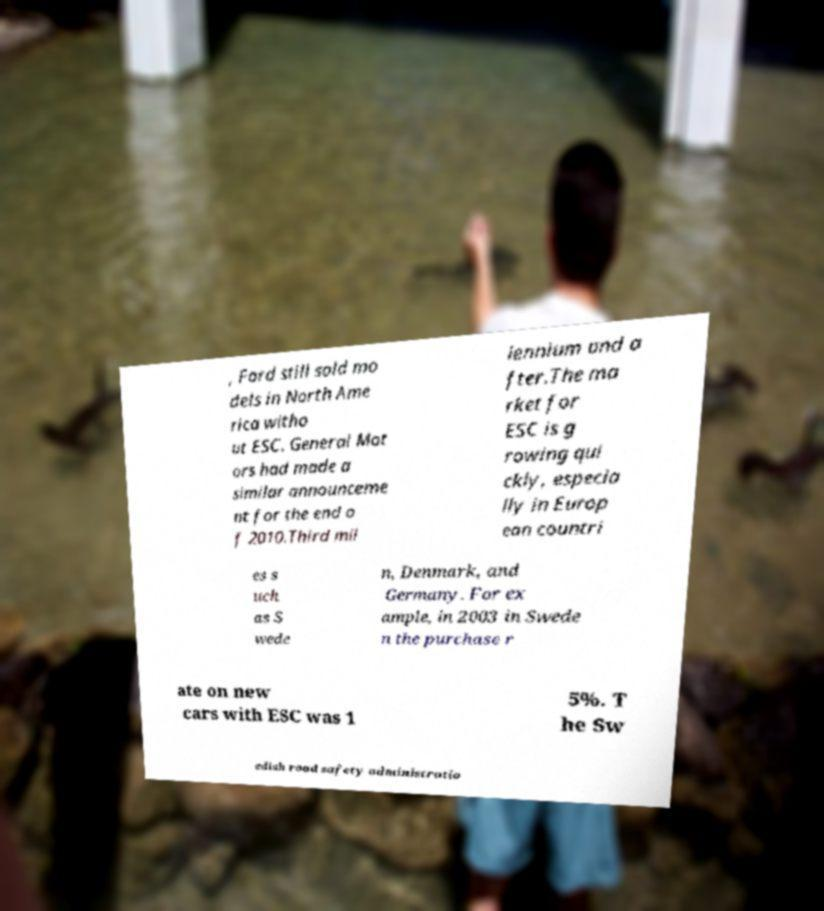Can you read and provide the text displayed in the image?This photo seems to have some interesting text. Can you extract and type it out for me? , Ford still sold mo dels in North Ame rica witho ut ESC. General Mot ors had made a similar announceme nt for the end o f 2010.Third mil lennium and a fter.The ma rket for ESC is g rowing qui ckly, especia lly in Europ ean countri es s uch as S wede n, Denmark, and Germany. For ex ample, in 2003 in Swede n the purchase r ate on new cars with ESC was 1 5%. T he Sw edish road safety administratio 